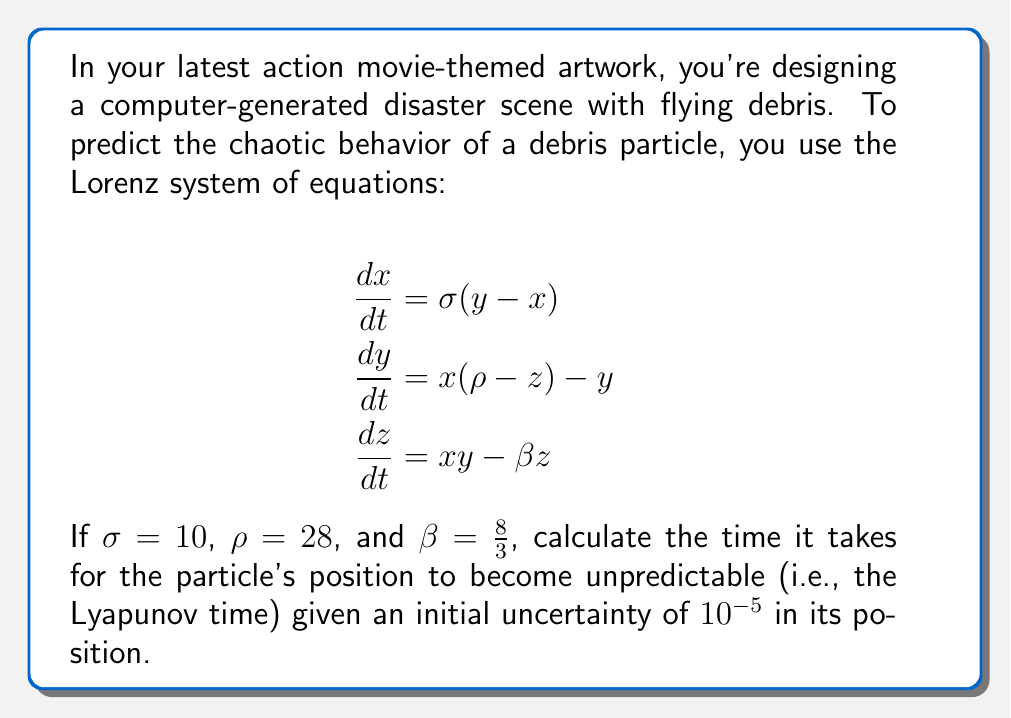Give your solution to this math problem. To solve this problem, we need to follow these steps:

1) The Lyapunov exponent ($\lambda$) for the Lorenz system with these parameters is approximately 0.9.

2) The Lyapunov time ($T_\lambda$) is defined as the inverse of the Lyapunov exponent:

   $$T_\lambda = \frac{1}{\lambda}$$

3) Substituting the value:

   $$T_\lambda = \frac{1}{0.9} \approx 1.11$$

4) The time it takes for an initial uncertainty to grow to a specific size is given by:

   $$t = T_\lambda \ln(\frac{\text{final uncertainty}}{\text{initial uncertainty}})$$

5) In this case, we want to know how long it takes for the uncertainty to grow to the size of the attractor, which is approximately 1. So:

   $$t = 1.11 \ln(\frac{1}{10^{-5}})$$

6) Simplify:
   
   $$t = 1.11 \ln(10^5) = 1.11 \cdot 5 \ln(10) \approx 12.8$$

Therefore, it takes approximately 12.8 time units for the particle's position to become unpredictable.
Answer: 12.8 time units 